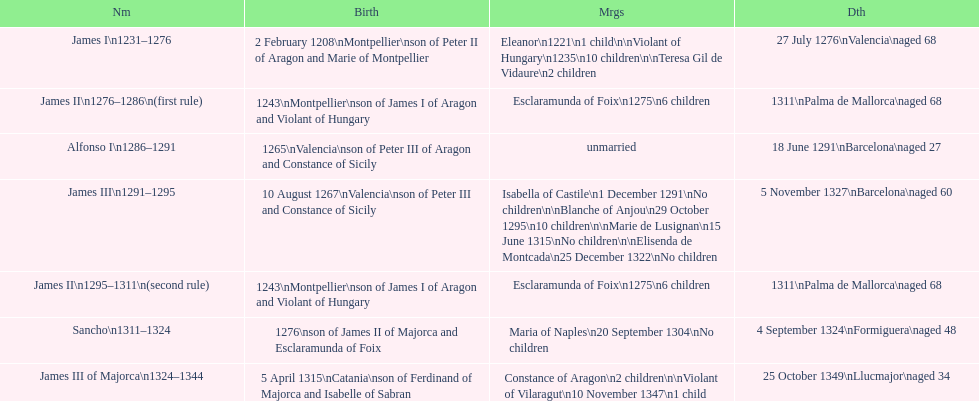James i and james ii both died at what age? 68. 